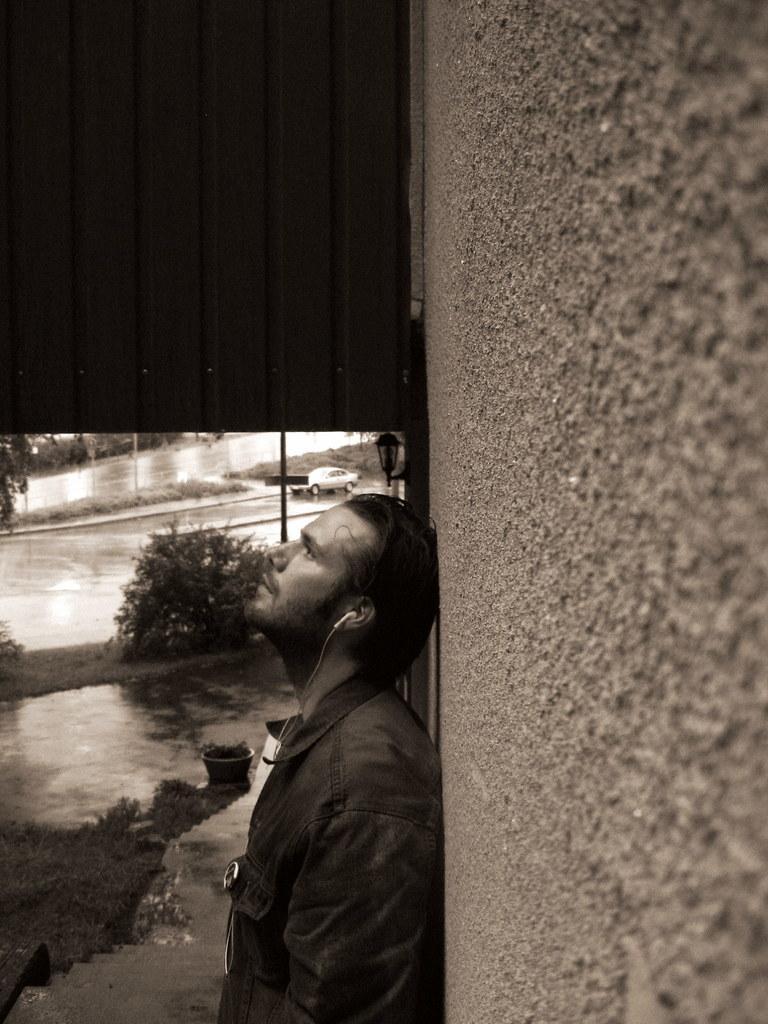Describe this image in one or two sentences. In this image there is a person standing near the wall. A lamp is attached to the wall. Few plants are on the grassland. Behind the person there is a pole. A car is on the road. Left side there are few trees on the grassland. Left bottom there is a staircase. 